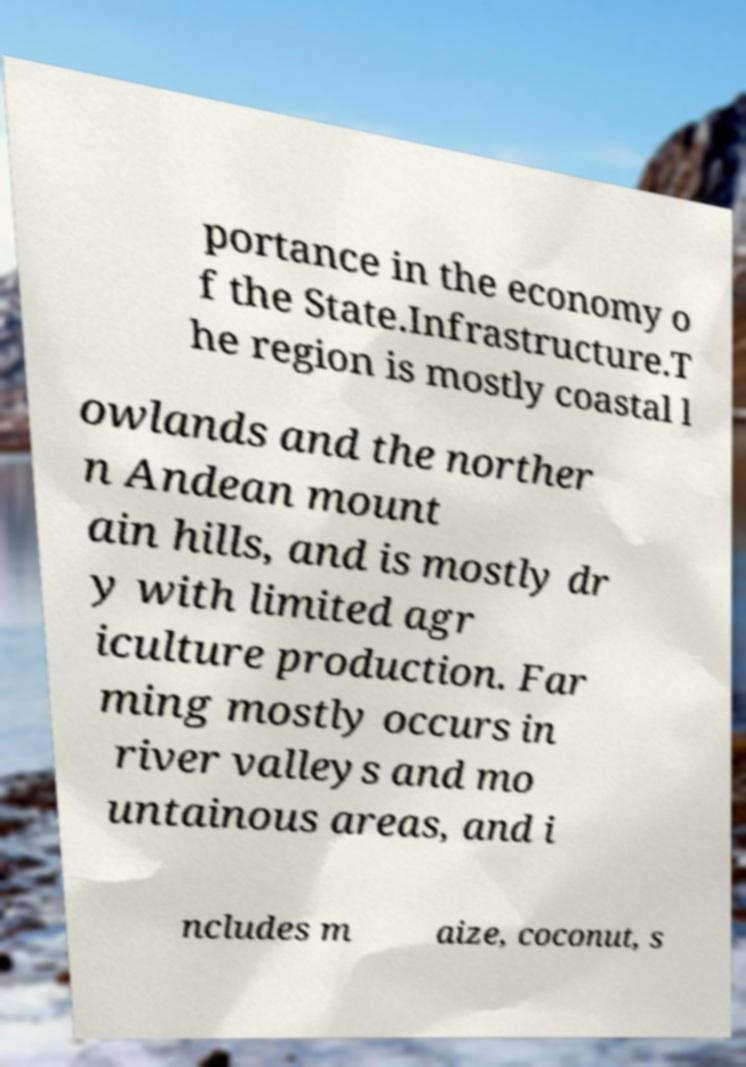Can you read and provide the text displayed in the image?This photo seems to have some interesting text. Can you extract and type it out for me? portance in the economy o f the State.Infrastructure.T he region is mostly coastal l owlands and the norther n Andean mount ain hills, and is mostly dr y with limited agr iculture production. Far ming mostly occurs in river valleys and mo untainous areas, and i ncludes m aize, coconut, s 